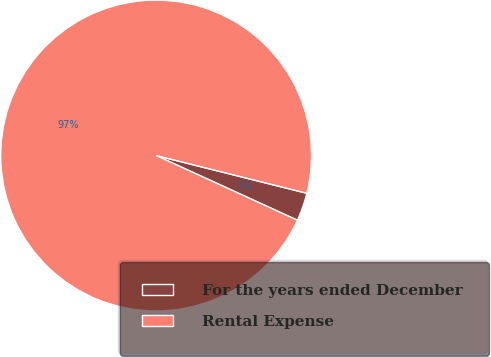<chart> <loc_0><loc_0><loc_500><loc_500><pie_chart><fcel>For the years ended December<fcel>Rental Expense<nl><fcel>2.93%<fcel>97.07%<nl></chart> 